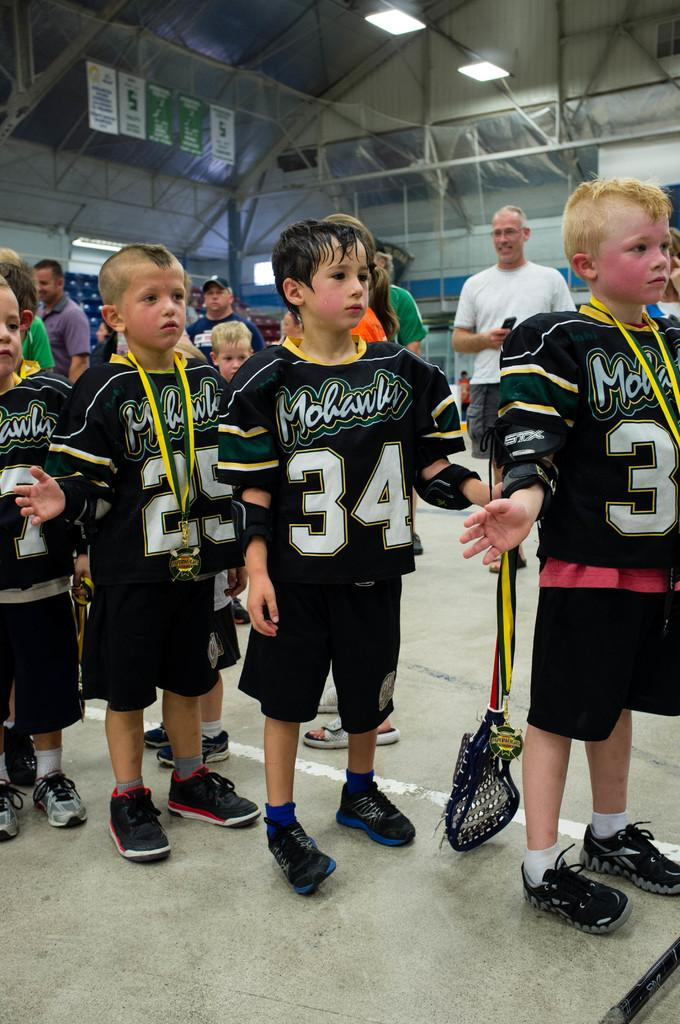What is the main subject of the image? The main subject of the image is a group of persons standing in the middle of the image. What can be seen in the background of the image? There is a net and a wall in the background of the image. What is the source of light in the image? There are two lights at the top of the image. What type of vest is the person in the image wearing? There is no vest visible in the image. What disease is being treated in the image? There is no indication of a disease or medical treatment in the image. 